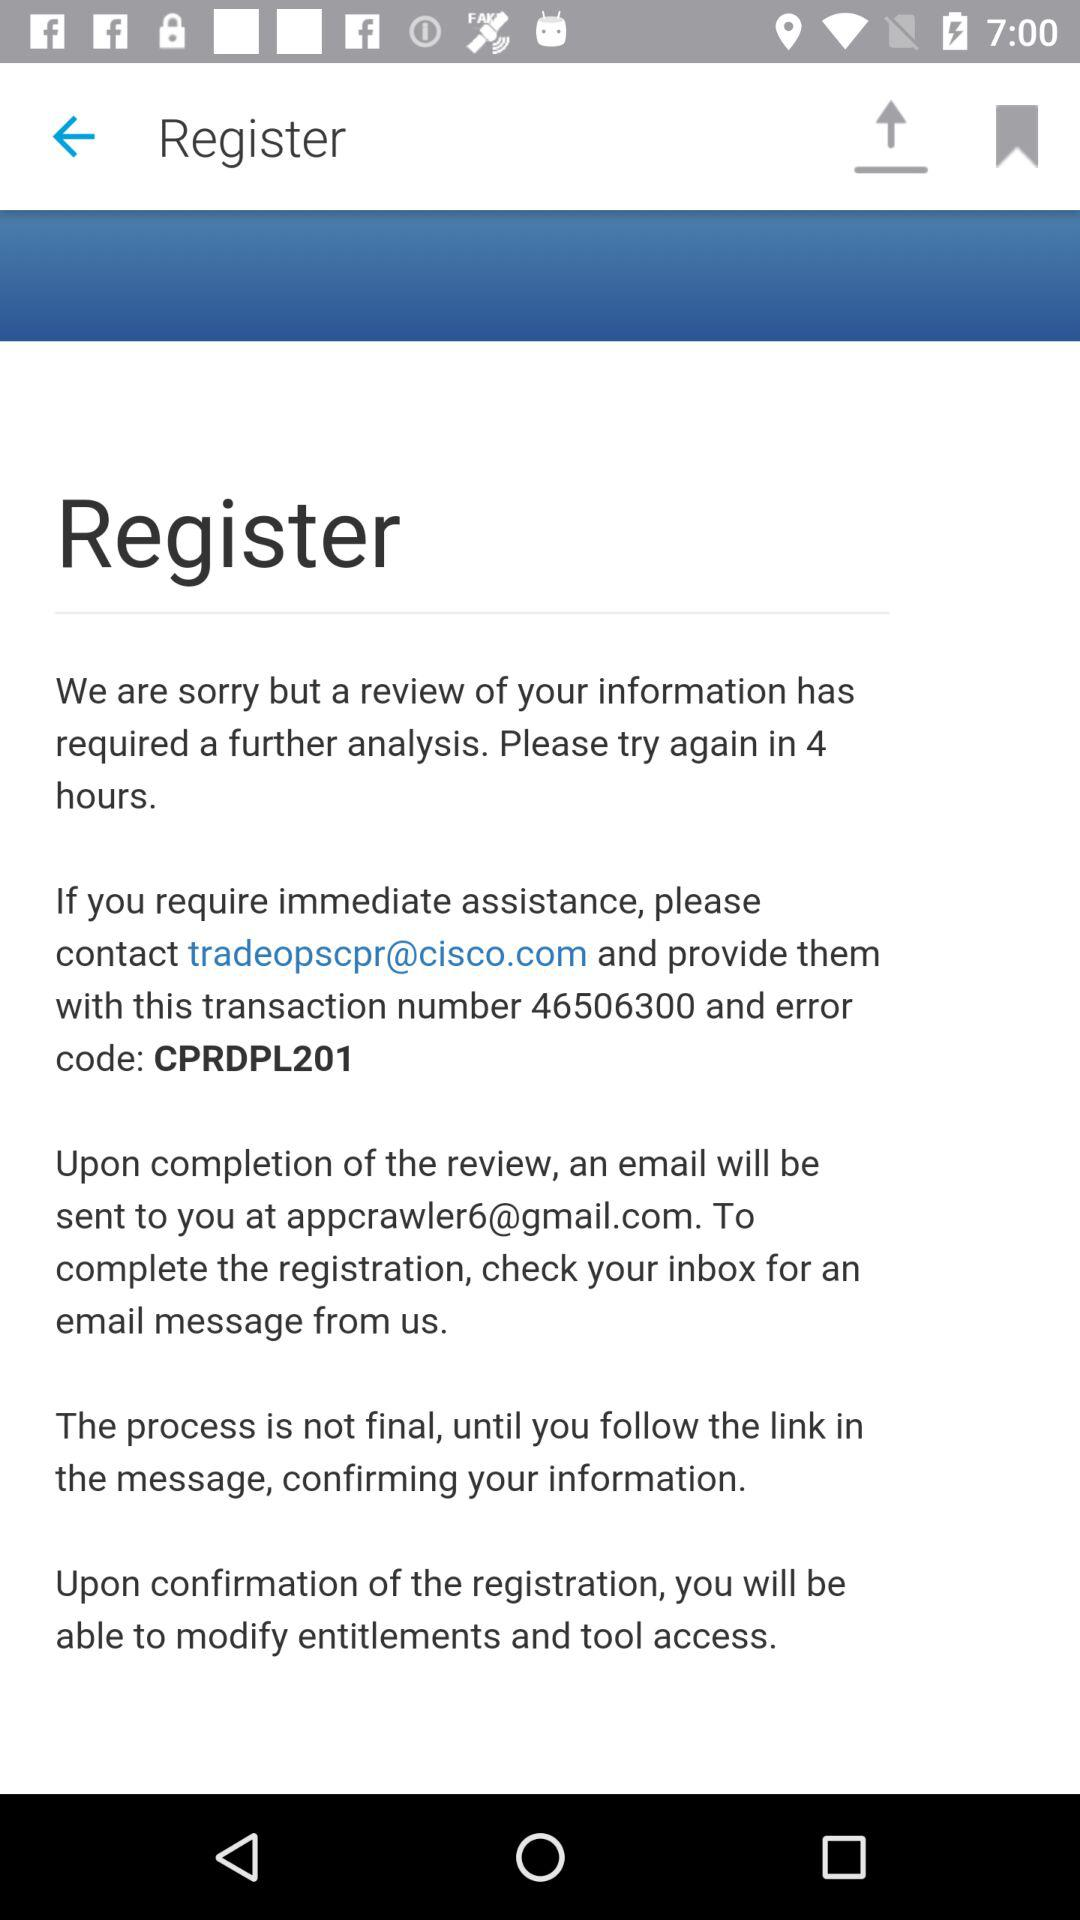What is the error code? The error code is "CPRDPL201". 